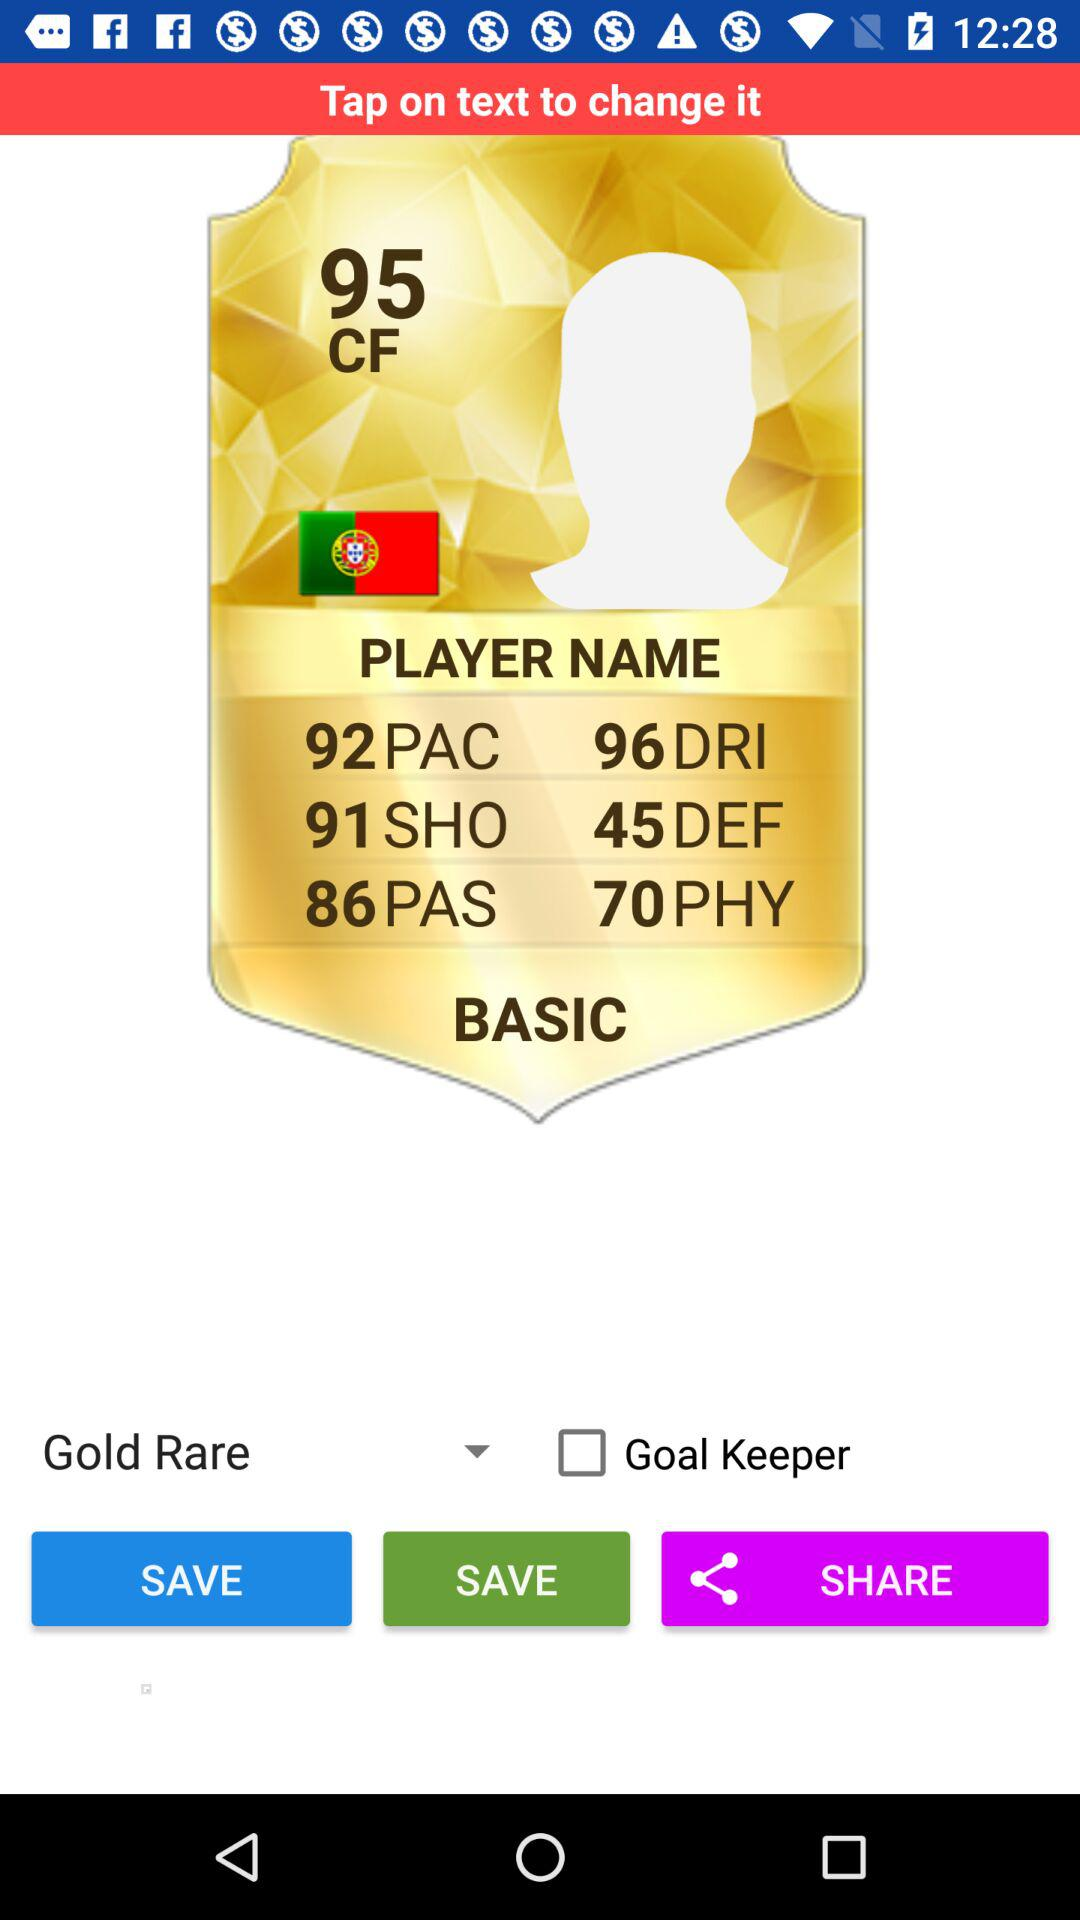What is the difference between the player's pace and defending?
Answer the question using a single word or phrase. 47 